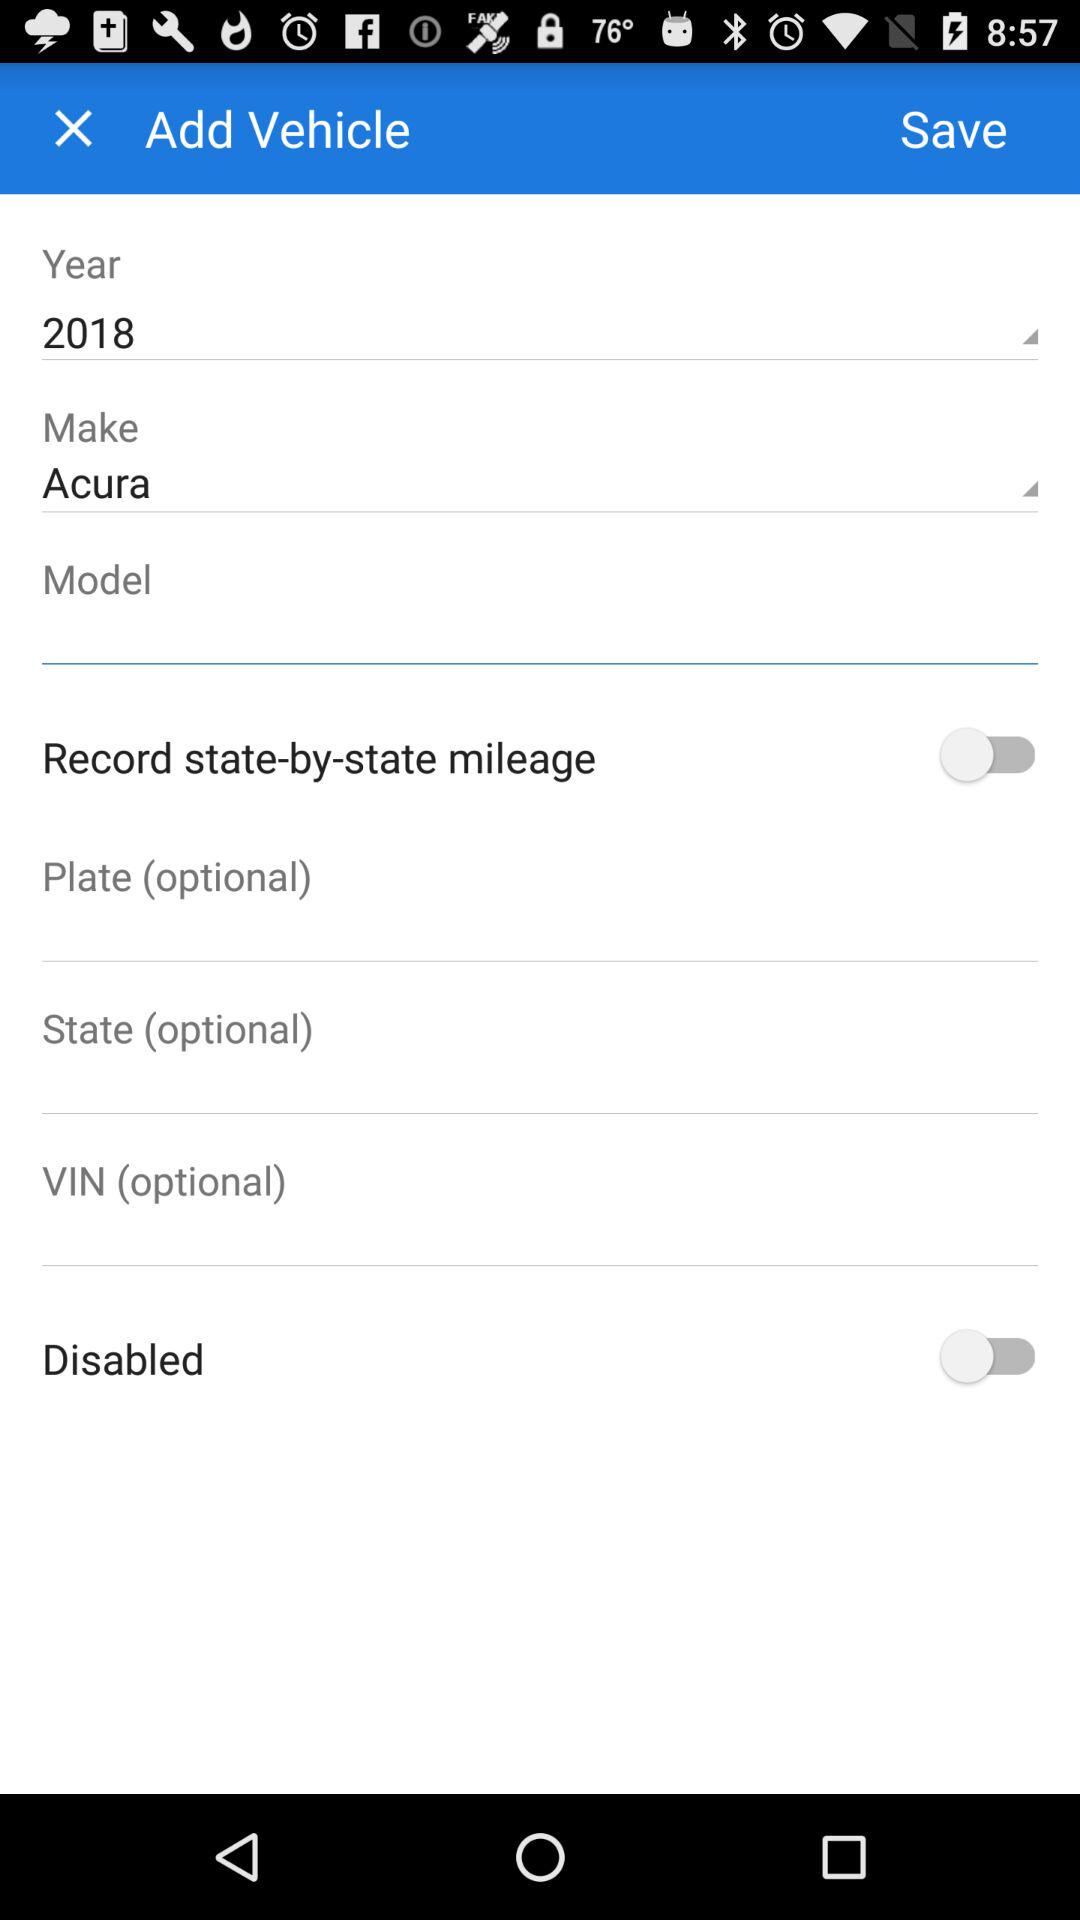Which is the selected year? The selected year is 2018. 